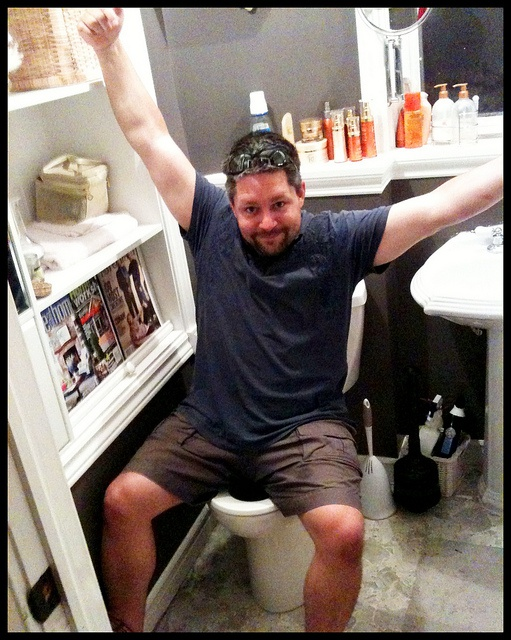Describe the objects in this image and their specific colors. I can see people in black, maroon, gray, and brown tones, toilet in black and gray tones, sink in black, white, darkgray, and gray tones, book in black, maroon, gray, and brown tones, and book in black, darkgray, lightgray, and gray tones in this image. 